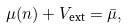Convert formula to latex. <formula><loc_0><loc_0><loc_500><loc_500>\mu ( n ) + V _ { \text {ext} } = \bar { \mu } ,</formula> 